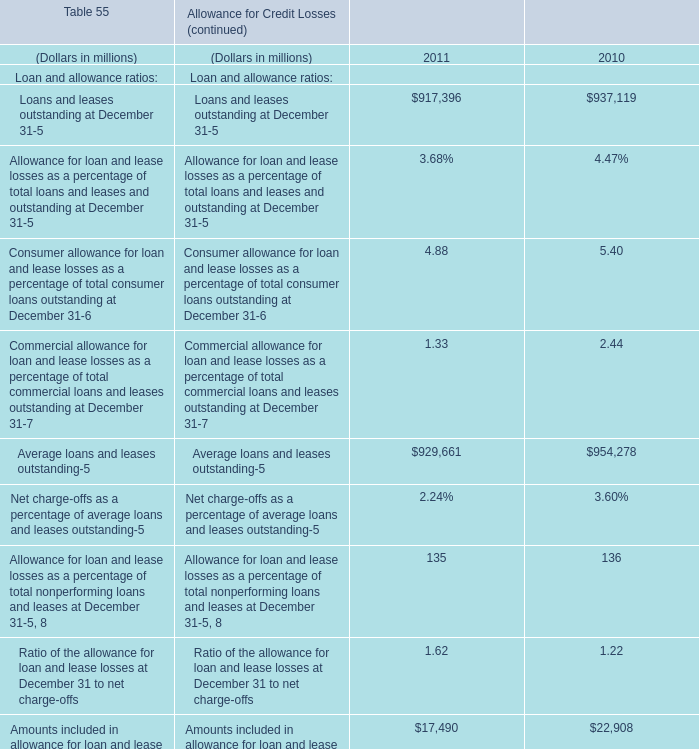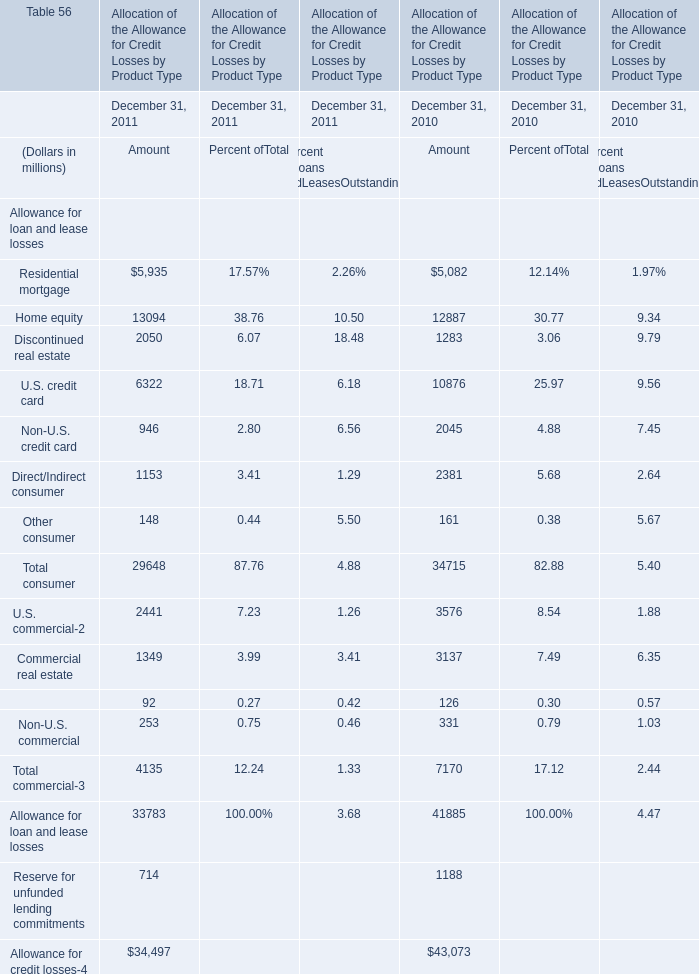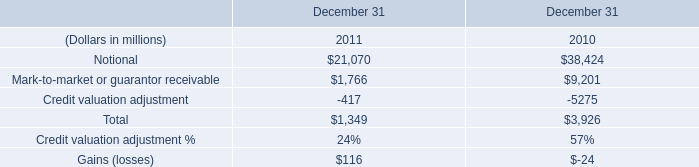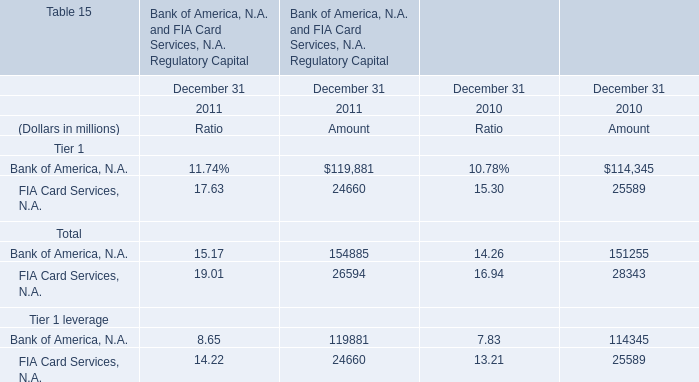What's the average of Amounts included in allowance for loan and lease losses that are excluded from nonperforming loans and leases in 2011and 2010? (in million) 
Computations: ((17490 + 22908) / 2)
Answer: 20199.0. 